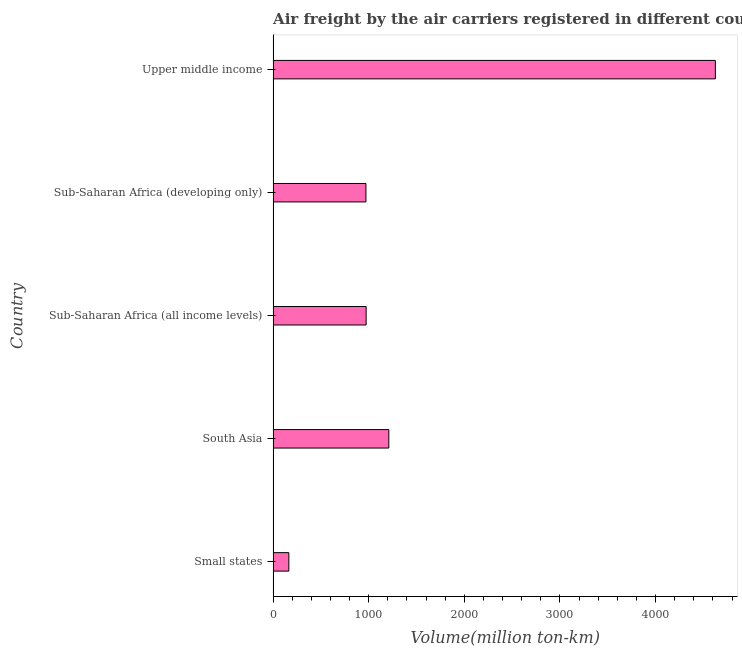Does the graph contain grids?
Offer a very short reply. No. What is the title of the graph?
Give a very brief answer. Air freight by the air carriers registered in different countries. What is the label or title of the X-axis?
Ensure brevity in your answer.  Volume(million ton-km). What is the air freight in Sub-Saharan Africa (all income levels)?
Your answer should be compact. 972.8. Across all countries, what is the maximum air freight?
Your answer should be compact. 4625.2. Across all countries, what is the minimum air freight?
Your response must be concise. 164.5. In which country was the air freight maximum?
Ensure brevity in your answer.  Upper middle income. In which country was the air freight minimum?
Make the answer very short. Small states. What is the sum of the air freight?
Offer a very short reply. 7943.2. What is the difference between the air freight in Sub-Saharan Africa (all income levels) and Upper middle income?
Ensure brevity in your answer.  -3652.4. What is the average air freight per country?
Your answer should be very brief. 1588.64. What is the median air freight?
Make the answer very short. 972.8. In how many countries, is the air freight greater than 200 million ton-km?
Your answer should be very brief. 4. What is the ratio of the air freight in Sub-Saharan Africa (all income levels) to that in Upper middle income?
Your response must be concise. 0.21. Is the air freight in Small states less than that in Sub-Saharan Africa (developing only)?
Your answer should be compact. Yes. What is the difference between the highest and the second highest air freight?
Ensure brevity in your answer.  3415.2. What is the difference between the highest and the lowest air freight?
Ensure brevity in your answer.  4460.7. How many bars are there?
Keep it short and to the point. 5. Are all the bars in the graph horizontal?
Your answer should be compact. Yes. How many countries are there in the graph?
Make the answer very short. 5. Are the values on the major ticks of X-axis written in scientific E-notation?
Your answer should be very brief. No. What is the Volume(million ton-km) of Small states?
Your response must be concise. 164.5. What is the Volume(million ton-km) in South Asia?
Give a very brief answer. 1210. What is the Volume(million ton-km) in Sub-Saharan Africa (all income levels)?
Provide a short and direct response. 972.8. What is the Volume(million ton-km) in Sub-Saharan Africa (developing only)?
Provide a succinct answer. 970.7. What is the Volume(million ton-km) in Upper middle income?
Make the answer very short. 4625.2. What is the difference between the Volume(million ton-km) in Small states and South Asia?
Offer a very short reply. -1045.5. What is the difference between the Volume(million ton-km) in Small states and Sub-Saharan Africa (all income levels)?
Provide a short and direct response. -808.3. What is the difference between the Volume(million ton-km) in Small states and Sub-Saharan Africa (developing only)?
Your response must be concise. -806.2. What is the difference between the Volume(million ton-km) in Small states and Upper middle income?
Your answer should be compact. -4460.7. What is the difference between the Volume(million ton-km) in South Asia and Sub-Saharan Africa (all income levels)?
Keep it short and to the point. 237.2. What is the difference between the Volume(million ton-km) in South Asia and Sub-Saharan Africa (developing only)?
Make the answer very short. 239.3. What is the difference between the Volume(million ton-km) in South Asia and Upper middle income?
Your response must be concise. -3415.2. What is the difference between the Volume(million ton-km) in Sub-Saharan Africa (all income levels) and Upper middle income?
Give a very brief answer. -3652.4. What is the difference between the Volume(million ton-km) in Sub-Saharan Africa (developing only) and Upper middle income?
Make the answer very short. -3654.5. What is the ratio of the Volume(million ton-km) in Small states to that in South Asia?
Your response must be concise. 0.14. What is the ratio of the Volume(million ton-km) in Small states to that in Sub-Saharan Africa (all income levels)?
Give a very brief answer. 0.17. What is the ratio of the Volume(million ton-km) in Small states to that in Sub-Saharan Africa (developing only)?
Offer a very short reply. 0.17. What is the ratio of the Volume(million ton-km) in Small states to that in Upper middle income?
Keep it short and to the point. 0.04. What is the ratio of the Volume(million ton-km) in South Asia to that in Sub-Saharan Africa (all income levels)?
Keep it short and to the point. 1.24. What is the ratio of the Volume(million ton-km) in South Asia to that in Sub-Saharan Africa (developing only)?
Your response must be concise. 1.25. What is the ratio of the Volume(million ton-km) in South Asia to that in Upper middle income?
Make the answer very short. 0.26. What is the ratio of the Volume(million ton-km) in Sub-Saharan Africa (all income levels) to that in Upper middle income?
Your answer should be compact. 0.21. What is the ratio of the Volume(million ton-km) in Sub-Saharan Africa (developing only) to that in Upper middle income?
Keep it short and to the point. 0.21. 